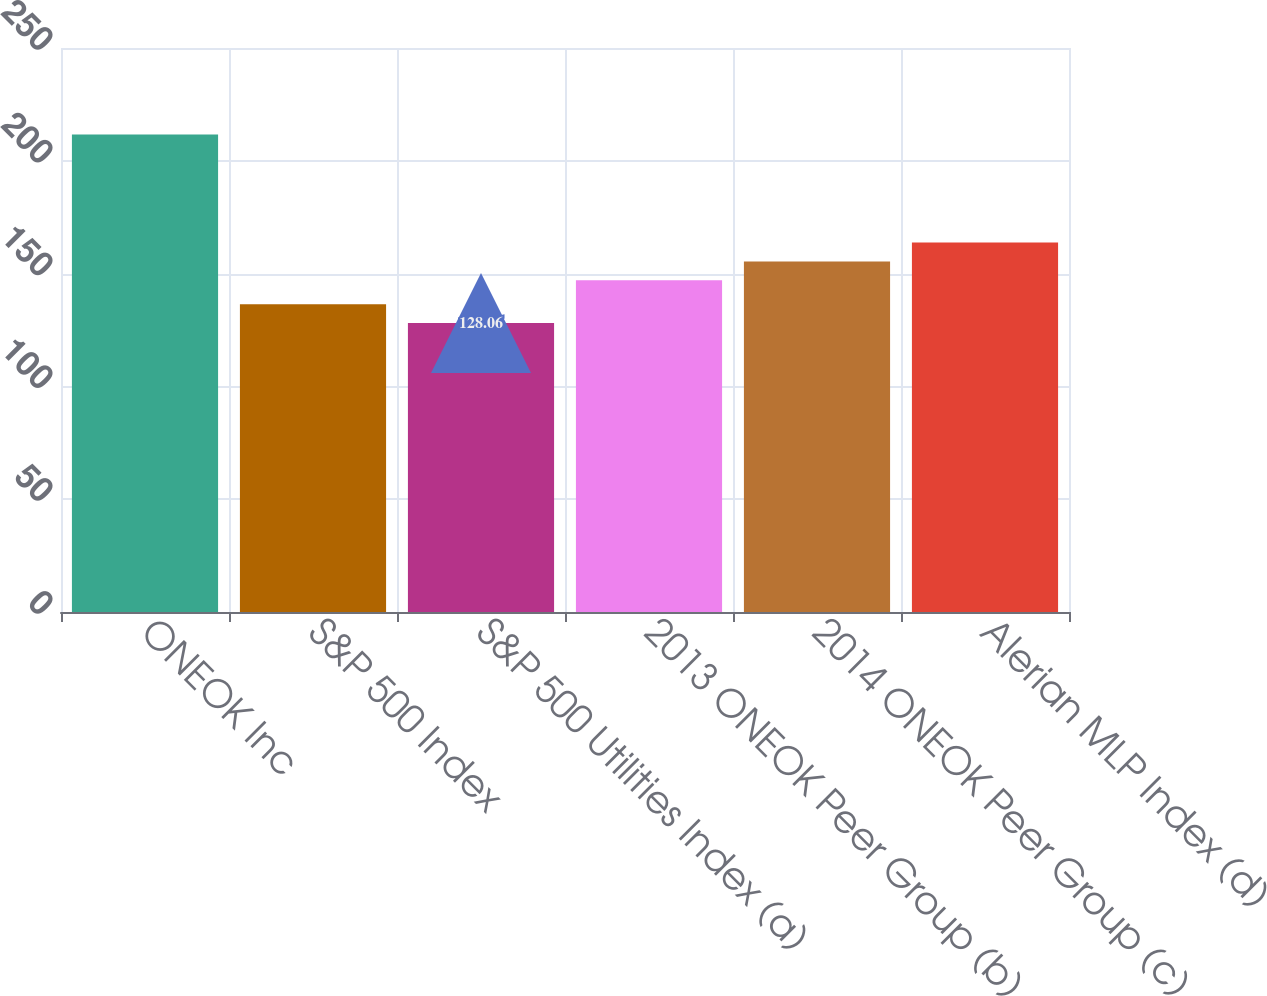<chart> <loc_0><loc_0><loc_500><loc_500><bar_chart><fcel>ONEOK Inc<fcel>S&P 500 Index<fcel>S&P 500 Utilities Index (a)<fcel>2013 ONEOK Peer Group (b)<fcel>2014 ONEOK Peer Group (c)<fcel>Alerian MLP Index (d)<nl><fcel>211.67<fcel>136.42<fcel>128.06<fcel>147.03<fcel>155.39<fcel>163.75<nl></chart> 